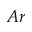Convert formula to latex. <formula><loc_0><loc_0><loc_500><loc_500>A r</formula> 